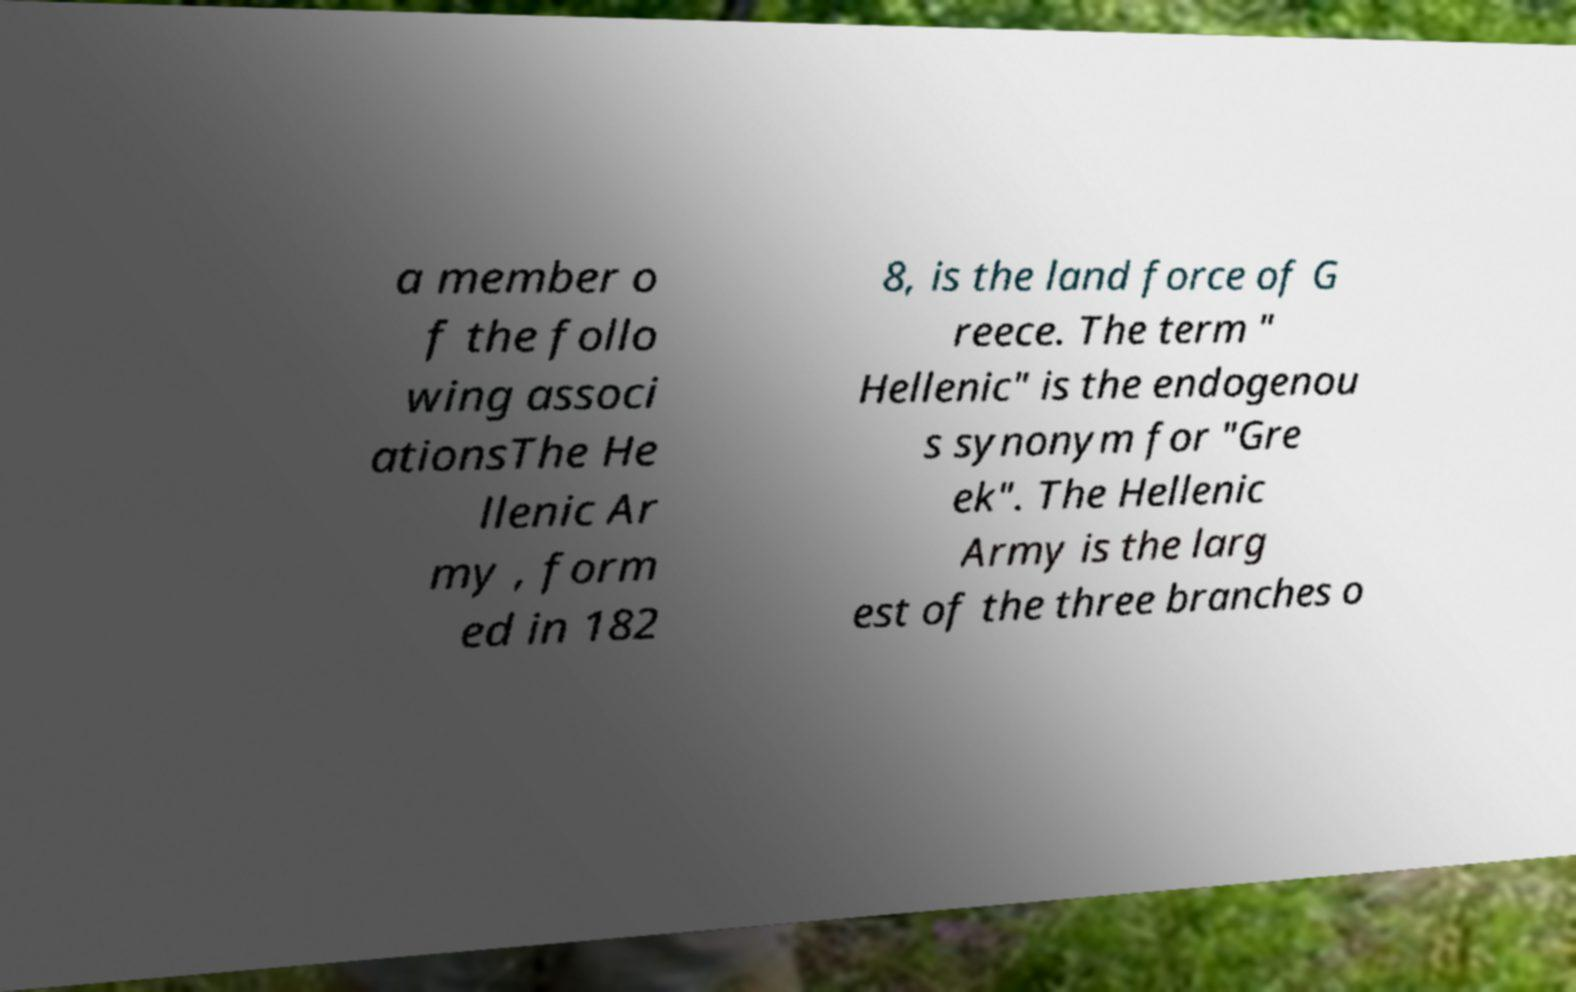I need the written content from this picture converted into text. Can you do that? a member o f the follo wing associ ationsThe He llenic Ar my , form ed in 182 8, is the land force of G reece. The term " Hellenic" is the endogenou s synonym for "Gre ek". The Hellenic Army is the larg est of the three branches o 